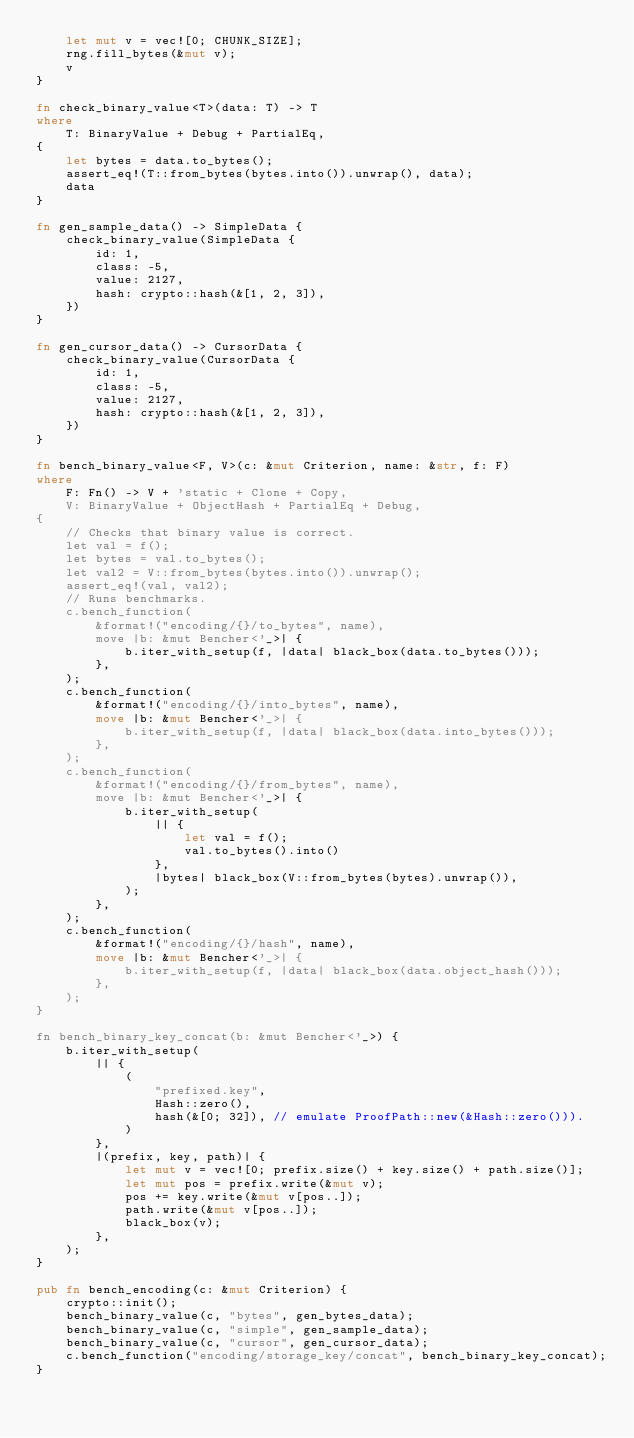<code> <loc_0><loc_0><loc_500><loc_500><_Rust_>    let mut v = vec![0; CHUNK_SIZE];
    rng.fill_bytes(&mut v);
    v
}

fn check_binary_value<T>(data: T) -> T
where
    T: BinaryValue + Debug + PartialEq,
{
    let bytes = data.to_bytes();
    assert_eq!(T::from_bytes(bytes.into()).unwrap(), data);
    data
}

fn gen_sample_data() -> SimpleData {
    check_binary_value(SimpleData {
        id: 1,
        class: -5,
        value: 2127,
        hash: crypto::hash(&[1, 2, 3]),
    })
}

fn gen_cursor_data() -> CursorData {
    check_binary_value(CursorData {
        id: 1,
        class: -5,
        value: 2127,
        hash: crypto::hash(&[1, 2, 3]),
    })
}

fn bench_binary_value<F, V>(c: &mut Criterion, name: &str, f: F)
where
    F: Fn() -> V + 'static + Clone + Copy,
    V: BinaryValue + ObjectHash + PartialEq + Debug,
{
    // Checks that binary value is correct.
    let val = f();
    let bytes = val.to_bytes();
    let val2 = V::from_bytes(bytes.into()).unwrap();
    assert_eq!(val, val2);
    // Runs benchmarks.
    c.bench_function(
        &format!("encoding/{}/to_bytes", name),
        move |b: &mut Bencher<'_>| {
            b.iter_with_setup(f, |data| black_box(data.to_bytes()));
        },
    );
    c.bench_function(
        &format!("encoding/{}/into_bytes", name),
        move |b: &mut Bencher<'_>| {
            b.iter_with_setup(f, |data| black_box(data.into_bytes()));
        },
    );
    c.bench_function(
        &format!("encoding/{}/from_bytes", name),
        move |b: &mut Bencher<'_>| {
            b.iter_with_setup(
                || {
                    let val = f();
                    val.to_bytes().into()
                },
                |bytes| black_box(V::from_bytes(bytes).unwrap()),
            );
        },
    );
    c.bench_function(
        &format!("encoding/{}/hash", name),
        move |b: &mut Bencher<'_>| {
            b.iter_with_setup(f, |data| black_box(data.object_hash()));
        },
    );
}

fn bench_binary_key_concat(b: &mut Bencher<'_>) {
    b.iter_with_setup(
        || {
            (
                "prefixed.key",
                Hash::zero(),
                hash(&[0; 32]), // emulate ProofPath::new(&Hash::zero())).
            )
        },
        |(prefix, key, path)| {
            let mut v = vec![0; prefix.size() + key.size() + path.size()];
            let mut pos = prefix.write(&mut v);
            pos += key.write(&mut v[pos..]);
            path.write(&mut v[pos..]);
            black_box(v);
        },
    );
}

pub fn bench_encoding(c: &mut Criterion) {
    crypto::init();
    bench_binary_value(c, "bytes", gen_bytes_data);
    bench_binary_value(c, "simple", gen_sample_data);
    bench_binary_value(c, "cursor", gen_cursor_data);
    c.bench_function("encoding/storage_key/concat", bench_binary_key_concat);
}
</code> 